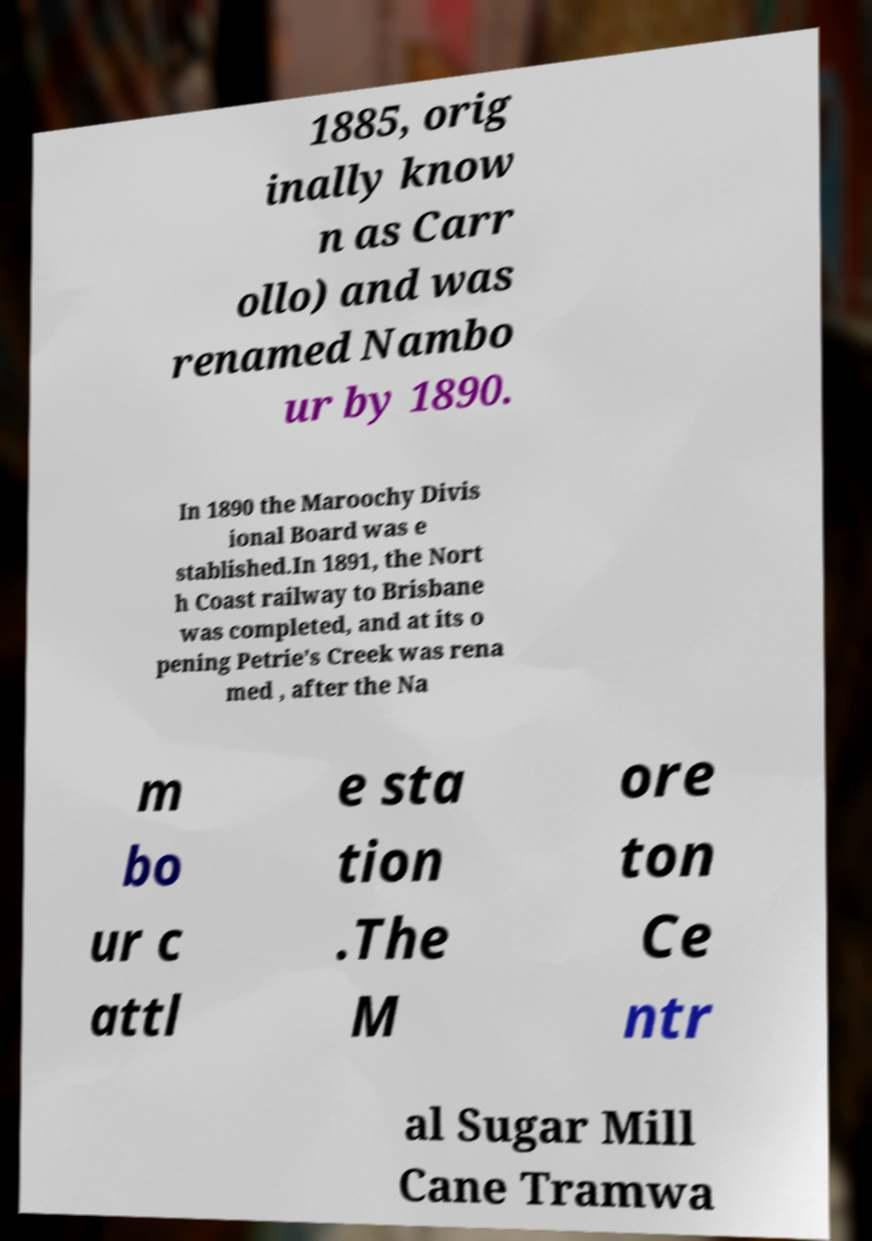Could you extract and type out the text from this image? 1885, orig inally know n as Carr ollo) and was renamed Nambo ur by 1890. In 1890 the Maroochy Divis ional Board was e stablished.In 1891, the Nort h Coast railway to Brisbane was completed, and at its o pening Petrie's Creek was rena med , after the Na m bo ur c attl e sta tion .The M ore ton Ce ntr al Sugar Mill Cane Tramwa 